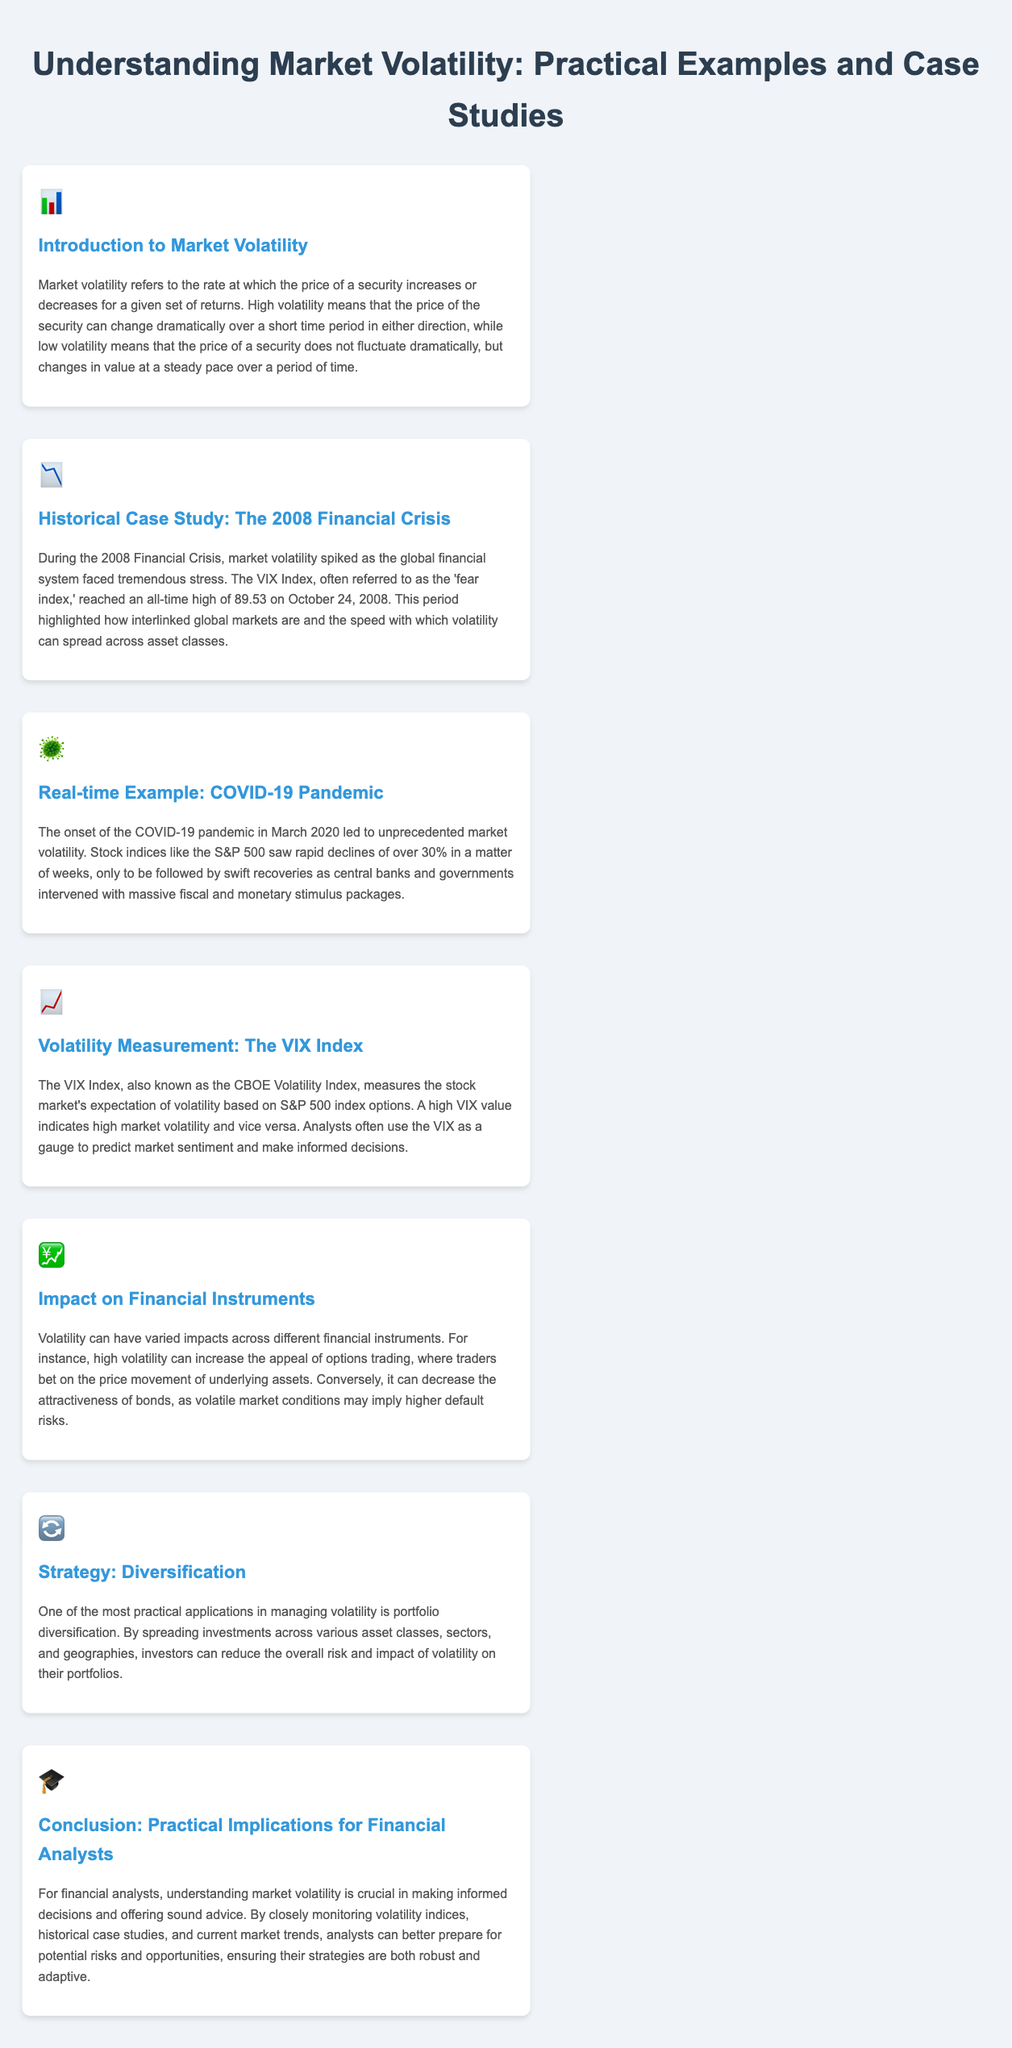what does market volatility refer to? Market volatility refers to the rate at which the price of a security increases or decreases for a given set of returns.
Answer: rate of price change what was the all-time high of the VIX Index during the 2008 Financial Crisis? The VIX Index reached an all-time high of 89.53 on October 24, 2008.
Answer: 89.53 what was the approximate decline of the S&P 500 in March 2020? The S&P 500 saw rapid declines of over 30% in a matter of weeks.
Answer: over 30% how is the VIX Index used by analysts? Analysts use the VIX as a gauge to predict market sentiment and make informed decisions.
Answer: to predict market sentiment what is one strategy to manage volatility? One strategy in managing volatility is portfolio diversification.
Answer: portfolio diversification what can high volatility imply for bonds? High volatility may imply higher default risks for bonds.
Answer: higher default risks what does a high VIX value indicate? A high VIX value indicates high market volatility.
Answer: high market volatility what event is referred to in the section titled 'Historical Case Study'? The event referred to is the 2008 Financial Crisis.
Answer: 2008 Financial Crisis how can financial analysts prepare for potential risks? Analysts can prepare for potential risks by closely monitoring volatility indices and current market trends.
Answer: monitoring volatility indices 